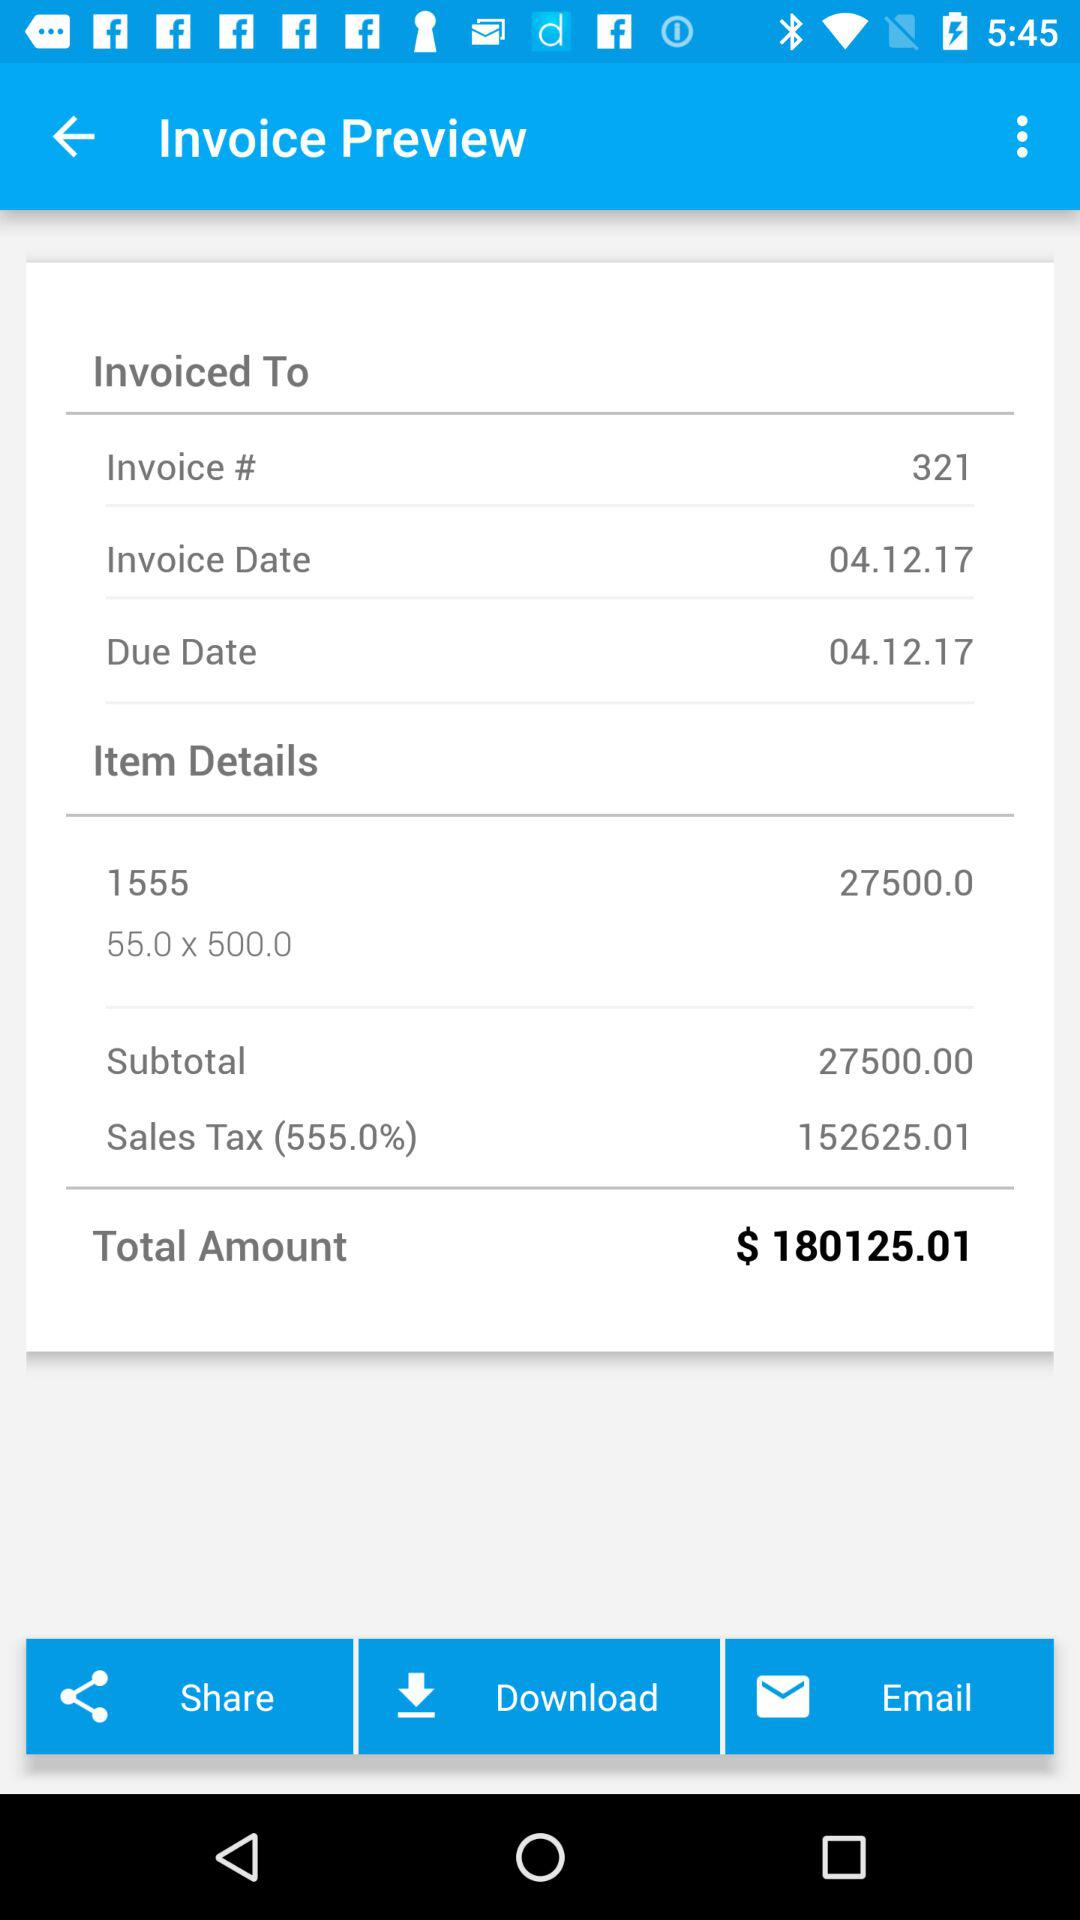What is the subtotal price? The subtotal price is 27500.00. 